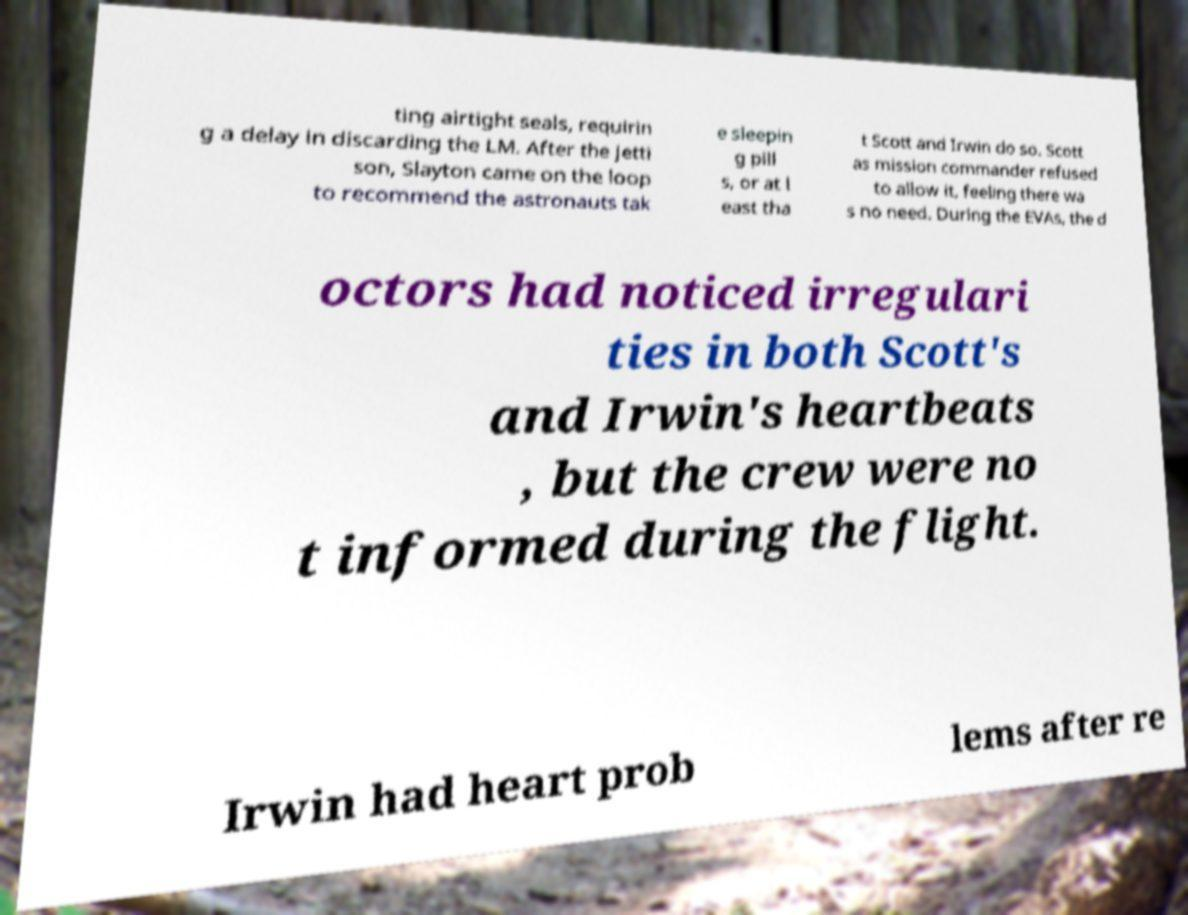Can you read and provide the text displayed in the image?This photo seems to have some interesting text. Can you extract and type it out for me? ting airtight seals, requirin g a delay in discarding the LM. After the jetti son, Slayton came on the loop to recommend the astronauts tak e sleepin g pill s, or at l east tha t Scott and Irwin do so. Scott as mission commander refused to allow it, feeling there wa s no need. During the EVAs, the d octors had noticed irregulari ties in both Scott's and Irwin's heartbeats , but the crew were no t informed during the flight. Irwin had heart prob lems after re 